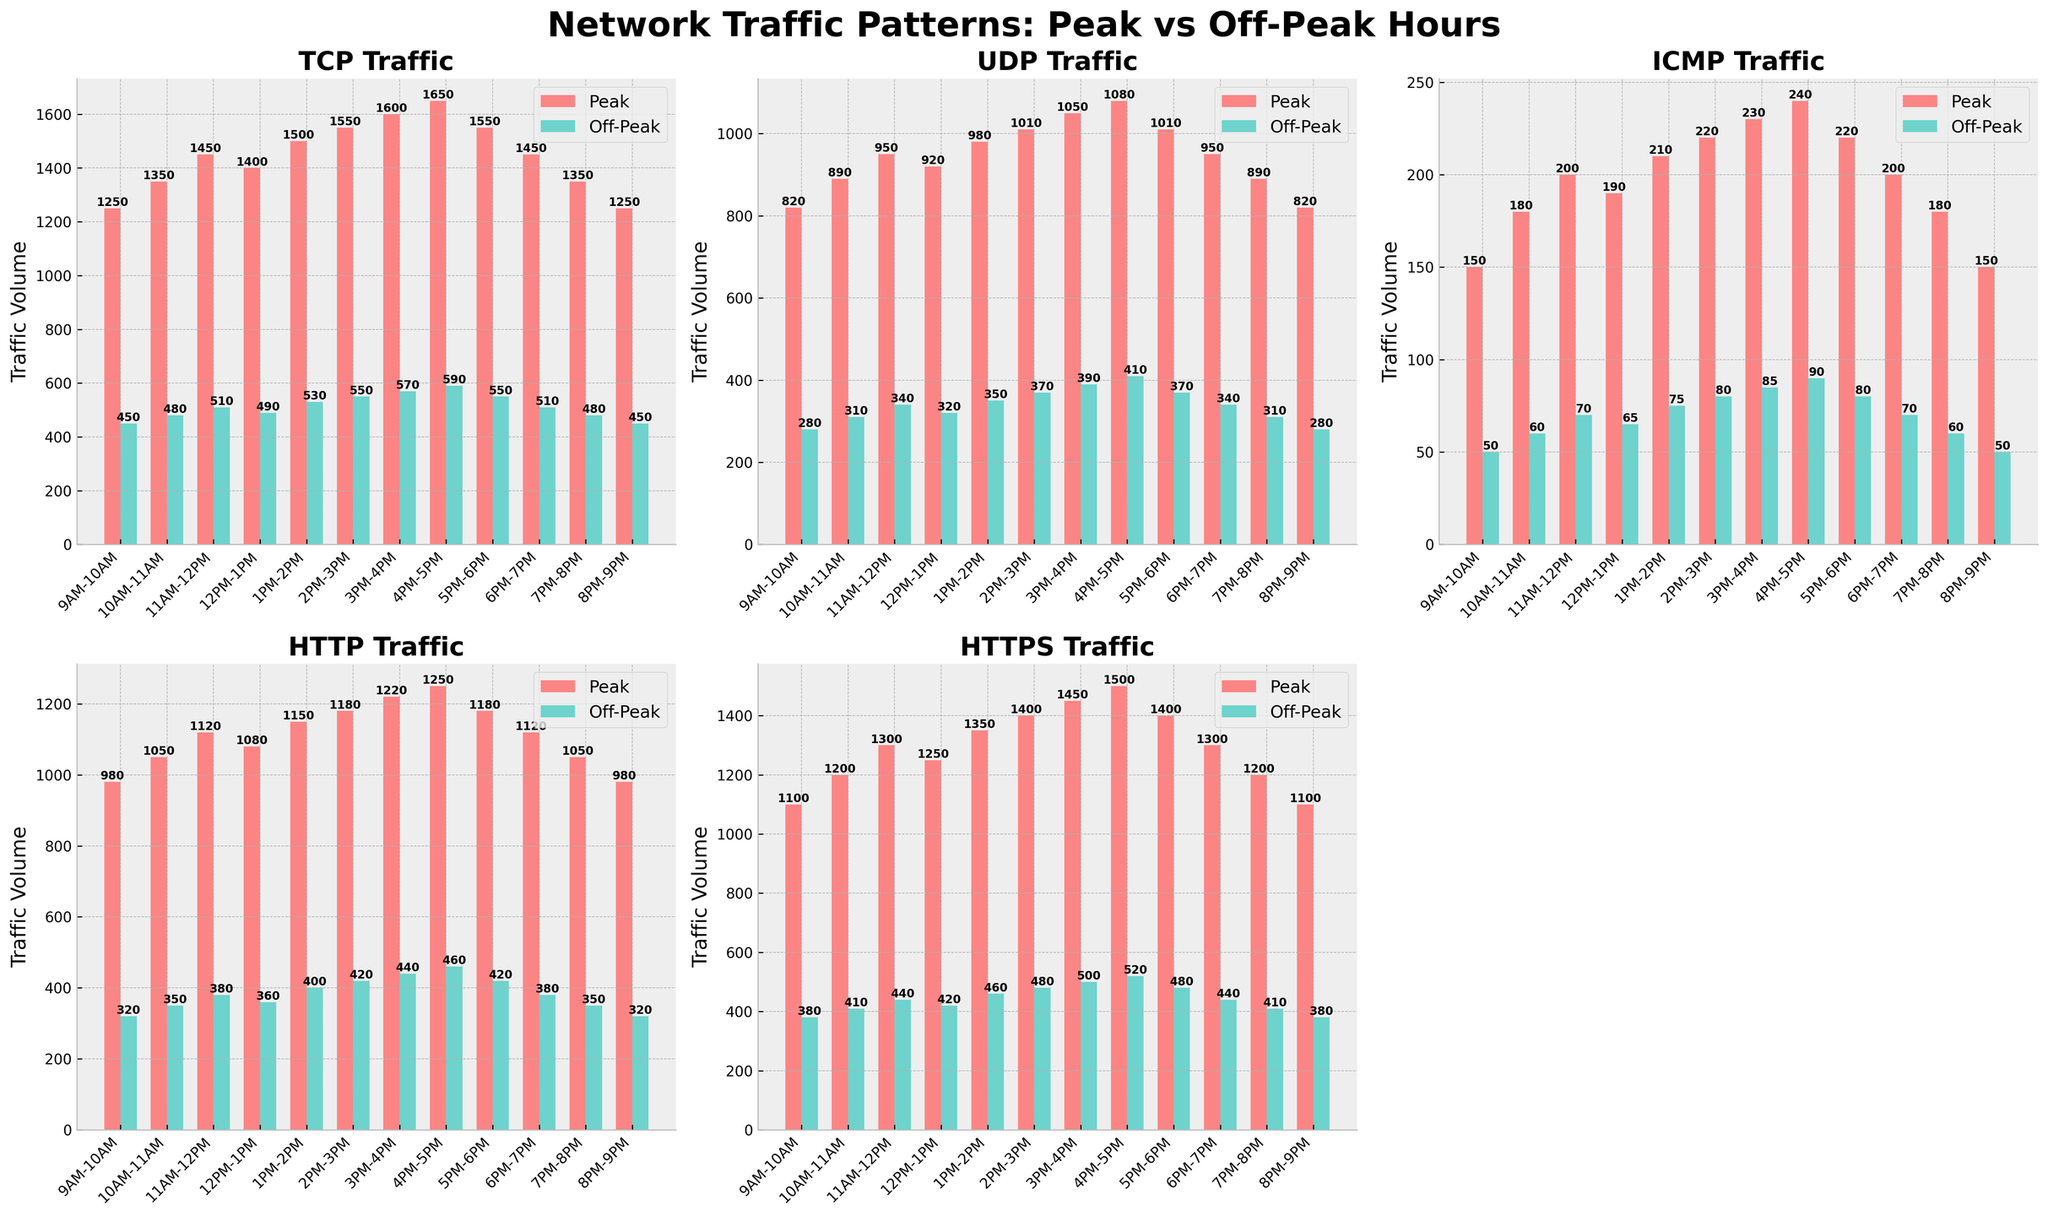What time period shows the highest peak TCP traffic? The highest peak TCP traffic corresponds to the tallest bar in the TCP subplot, colored red. By comparing the bars across different time periods, the highest is during 4PM-5PM with a peak value of 1650.
Answer: 4PM-5PM How much more peak traffic does HTTP have compared to ICMP on average? Add all peak HTTP values and peak ICMP values across time periods and divide each sum by the number of periods (12). Peak HTTP total is 12,230 and Peak ICMP total is 2150. The averages are 12,230/12 ≈ 1019.2 for HTTP and 2150/12 ≈ 179.2 for ICMP. The difference is approximately 1019.2 - 179.2 ≈ 840.
Answer: 840 During which time period is the ratio of peak HTTPS traffic to off-peak HTTPS traffic the highest? Calculate the ratio of peak to off-peak HTTPS traffic for each time period. The ratios are as follows: 9AM-10AM: 1100/380 ≈ 2.89, 10AM-11AM: 1200/410 ≈ 2.93, 11AM-12PM: 1300/440 ≈ 2.95, 12PM-1PM: 1250/420 ≈ 2.98, 1PM-2PM: 1350/460 ≈ 2.93, 2PM-3PM: 1400/480 ≈ 2.92, 3PM-4PM: 1450/500 ≈ 2.90, 4PM-5PM: 1500/520 ≈ 2.88, 5PM-6PM: 1400/480 ≈ 2.92, 6PM-7PM: 1300/440 ≈ 2.95, 7PM-8PM: 1200/410 ≈ 2.93, 8PM-9PM: 1100/380 ≈ 2.89. The highest ratio is during 12PM-1PM with a value of 2.98.
Answer: 12PM-1PM Is there a time period where off-peak UDP traffic exceeds 400? Examine the heights of the green bars for UDP subplot corresponding to off-peak traffic. The only time periods where the off-peak UDP traffic exceeds 400 are 1PM-2PM (350), 2PM-3PM (370), 3PM-4PM (390), and 4PM-5PM (410). Thus, 4PM-5PM exceeds 400.
Answer: 4PM-5PM How does the pattern of peak and off-peak ICMP traffic compare visually? Observe the height of the bars in the ICMP subplot. The red bars (peak traffic) are consistently higher than the green bars (off-peak traffic) for each time period, following a proportional pattern where peak values are generally 3 to 4 times higher than off-peak values.
Answer: Peak traffic is consistently 3 to 4 times higher than off-peak traffic 